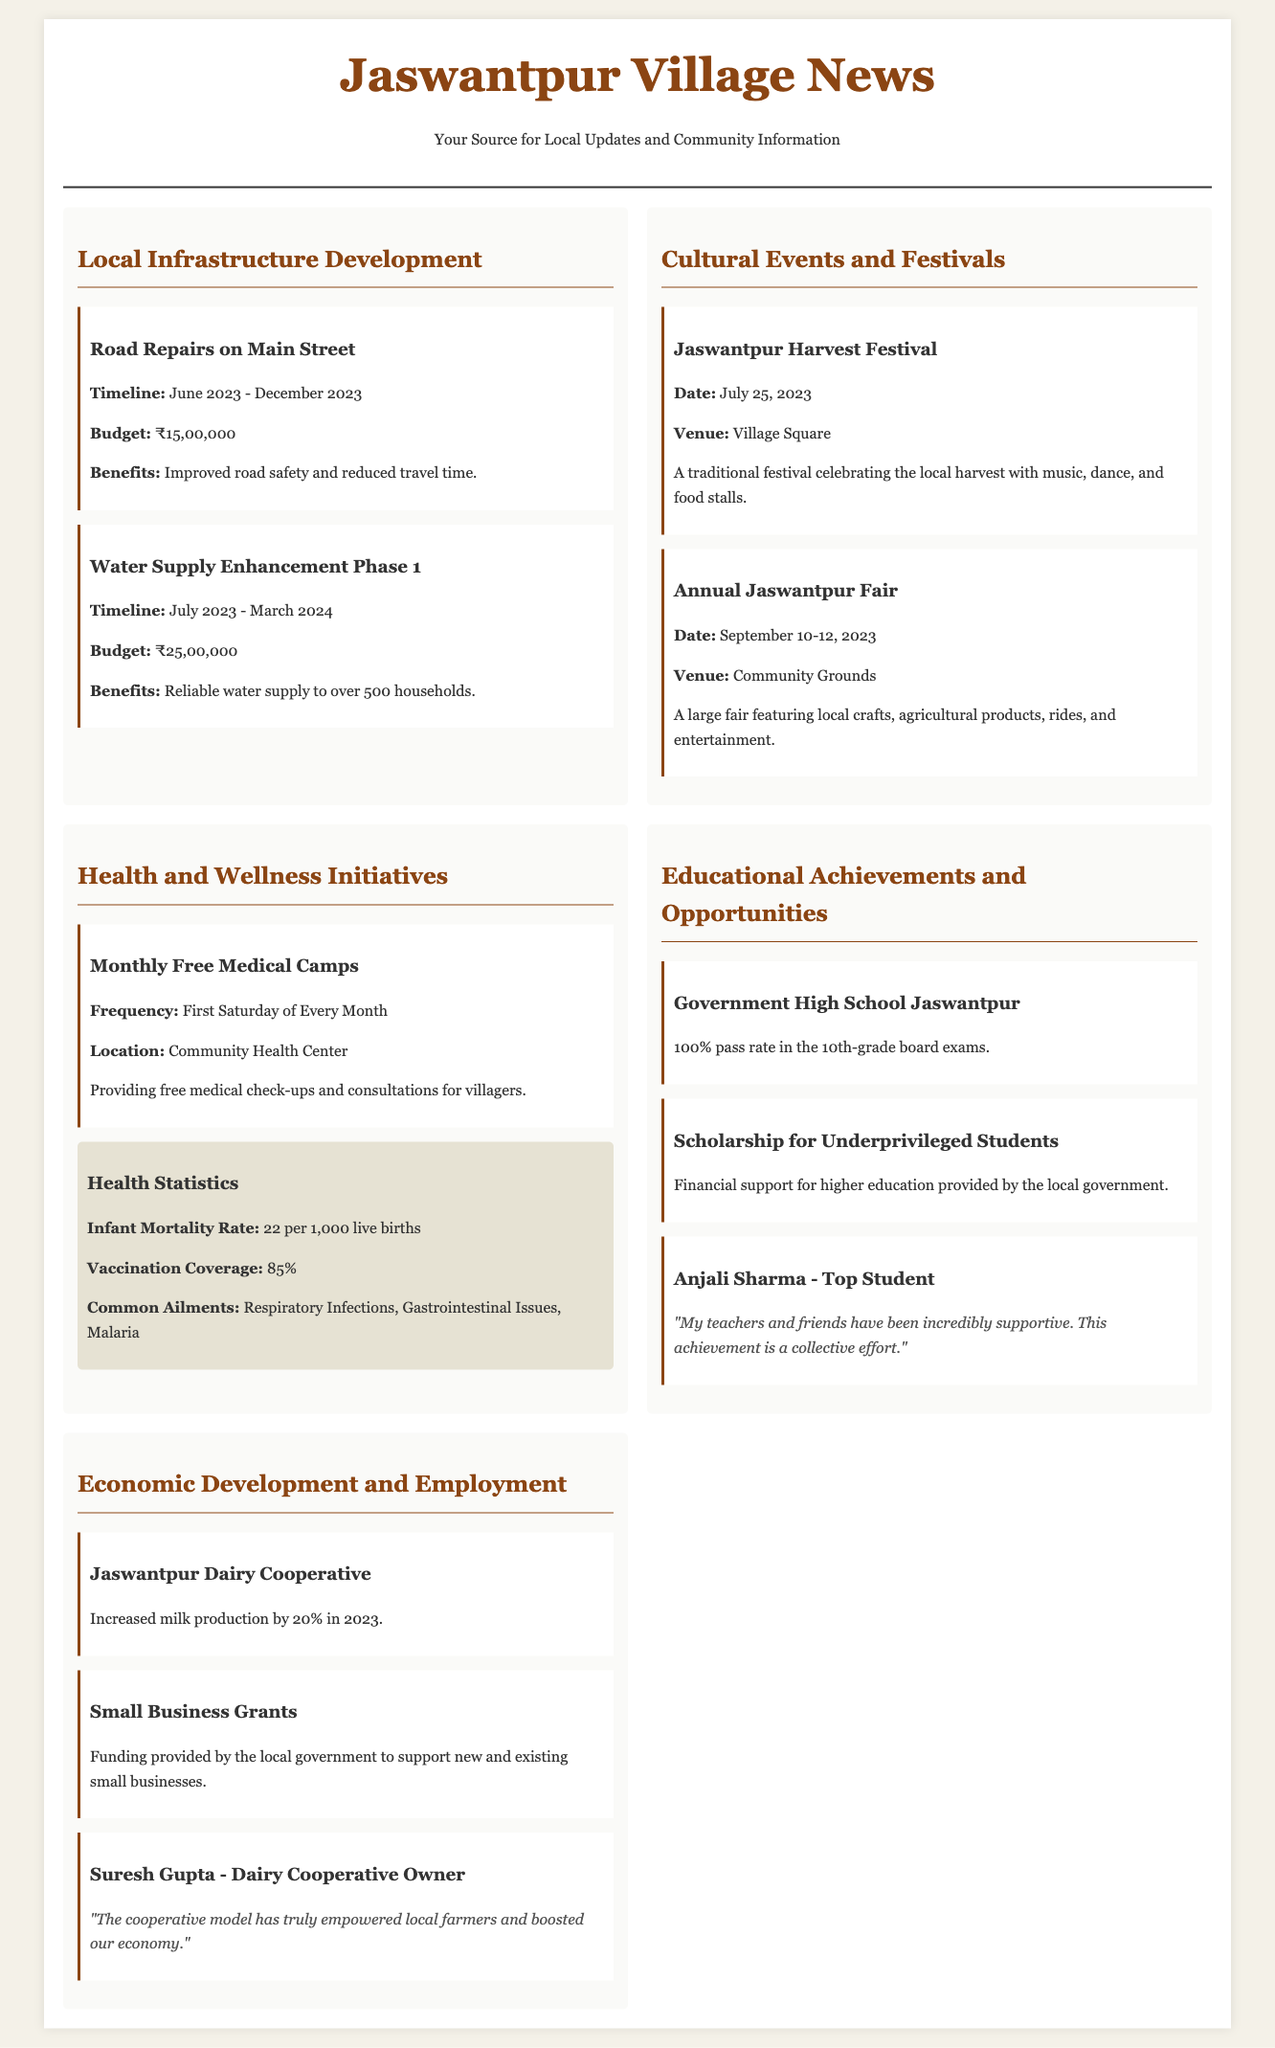What is the budget for the Water Supply Enhancement Phase 1? The budget for the water supply enhancement project is mentioned in the document as ₹25,00,000.
Answer: ₹25,00,000 When will the Jaswantpur Harvest Festival take place? The date of the Jaswantpur Harvest Festival is specified in the document as July 25, 2023.
Answer: July 25, 2023 What is the infant mortality rate reported in the health statistics? The infant mortality rate is reported as 22 per 1,000 live births.
Answer: 22 per 1,000 live births Which school achieved a 100% pass rate in the 10th-grade board exams? The document states that Government High School Jaswantpur achieved a 100% pass rate.
Answer: Government High School Jaswantpur Who is the owner of the Jaswantpur Dairy Cooperative? The document mentions Suresh Gupta as the owner of the dairy cooperative.
Answer: Suresh Gupta What type of initiative is being provided on the first Saturday of every month? The document specifies that free medical check-ups and consultations are provided monthly.
Answer: Free Medical Camps How long is the timeline for road repairs on Main Street? The timeline for the road repairs is stated as June 2023 - December 2023.
Answer: June 2023 - December 2023 What significant increase in milk production was reported for the dairy cooperative? The document indicates an increase of 20% in milk production for 2023.
Answer: 20% What type of financial support is mentioned for underprivileged students? The document refers to a scholarship program for higher education as financial support.
Answer: Scholarship for Underprivileged Students 